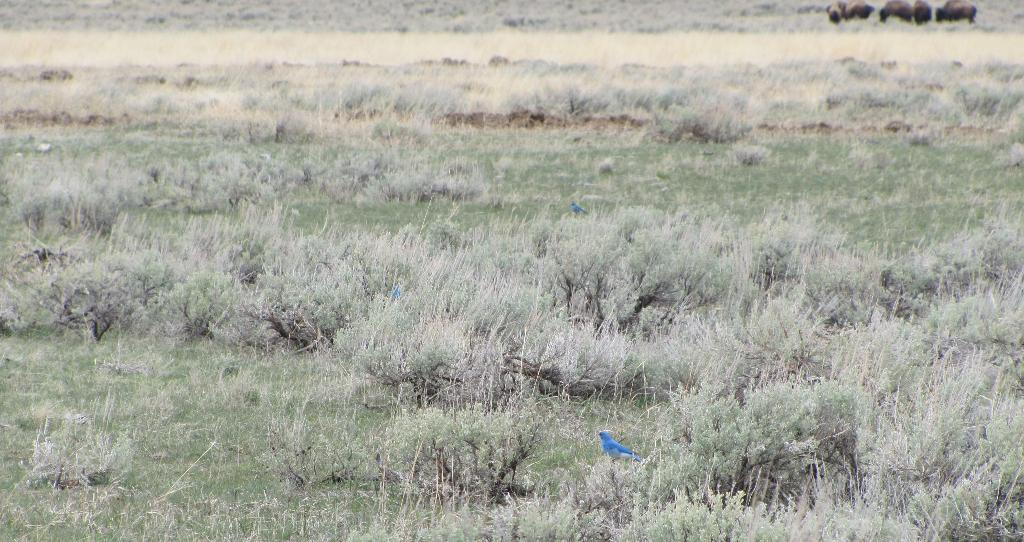What type of living organisms can be seen in the image? Birds can be seen in the image. What type of vegetation is present in the image? There are shrubs in the image. What can be seen in the background of the image? There are animals visible in the background of the image. What type of print can be seen on the birds' wings in the image? There is no print visible on the birds' wings in the image. What is the shape of the heart in the image? There is no heart present in the image. 